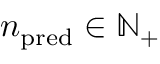<formula> <loc_0><loc_0><loc_500><loc_500>n _ { p r e d } \in { \mathbb { N } } _ { + }</formula> 